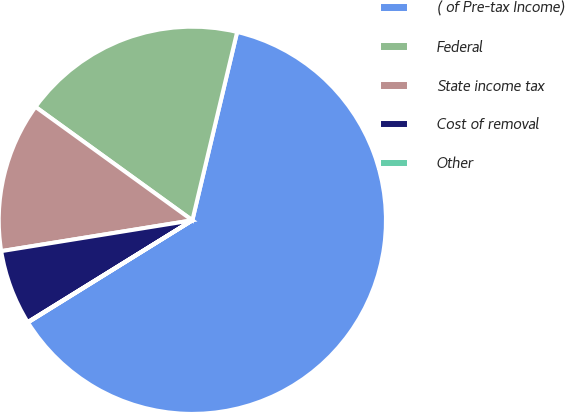Convert chart. <chart><loc_0><loc_0><loc_500><loc_500><pie_chart><fcel>( of Pre-tax Income)<fcel>Federal<fcel>State income tax<fcel>Cost of removal<fcel>Other<nl><fcel>62.43%<fcel>18.75%<fcel>12.51%<fcel>6.27%<fcel>0.03%<nl></chart> 